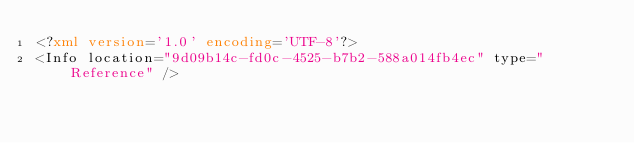<code> <loc_0><loc_0><loc_500><loc_500><_XML_><?xml version='1.0' encoding='UTF-8'?>
<Info location="9d09b14c-fd0c-4525-b7b2-588a014fb4ec" type="Reference" /></code> 